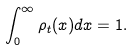Convert formula to latex. <formula><loc_0><loc_0><loc_500><loc_500>\int _ { 0 } ^ { \infty } \rho _ { t } ( x ) d x = 1 .</formula> 